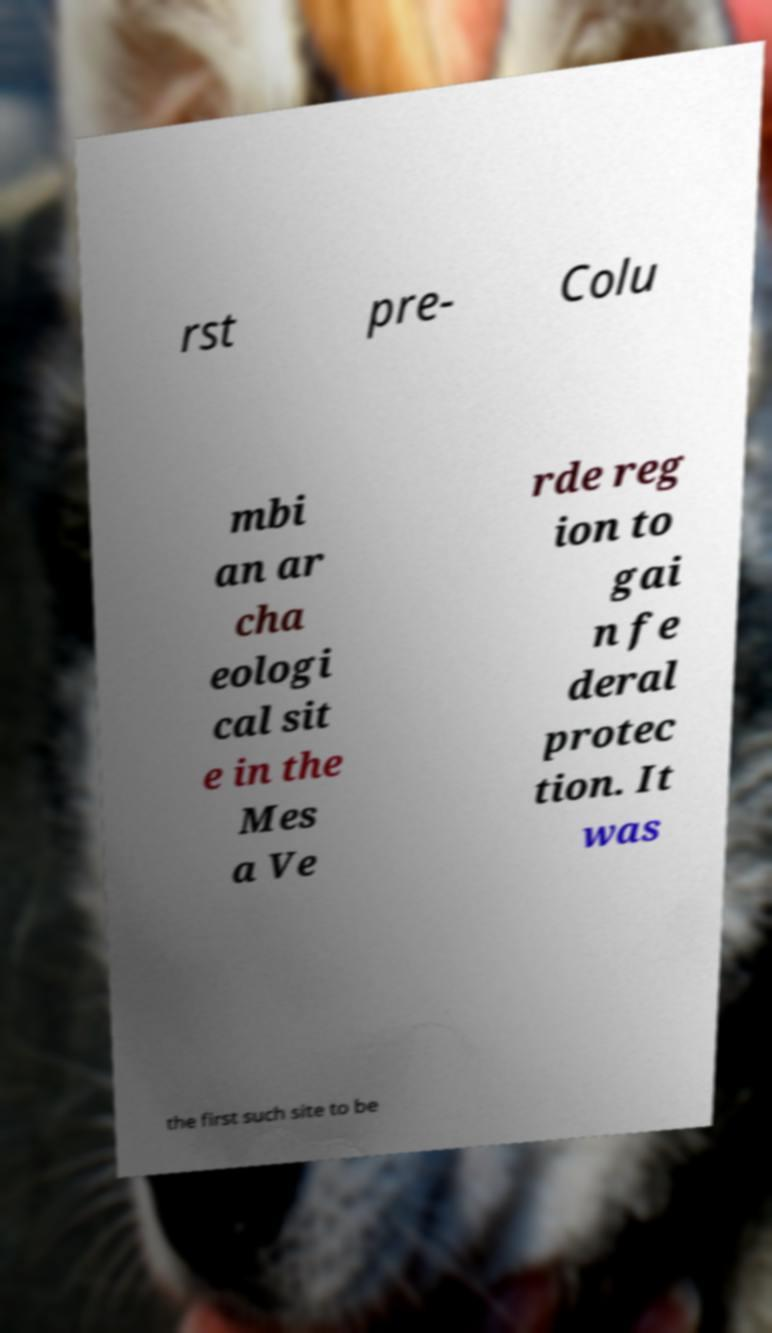Could you extract and type out the text from this image? rst pre- Colu mbi an ar cha eologi cal sit e in the Mes a Ve rde reg ion to gai n fe deral protec tion. It was the first such site to be 